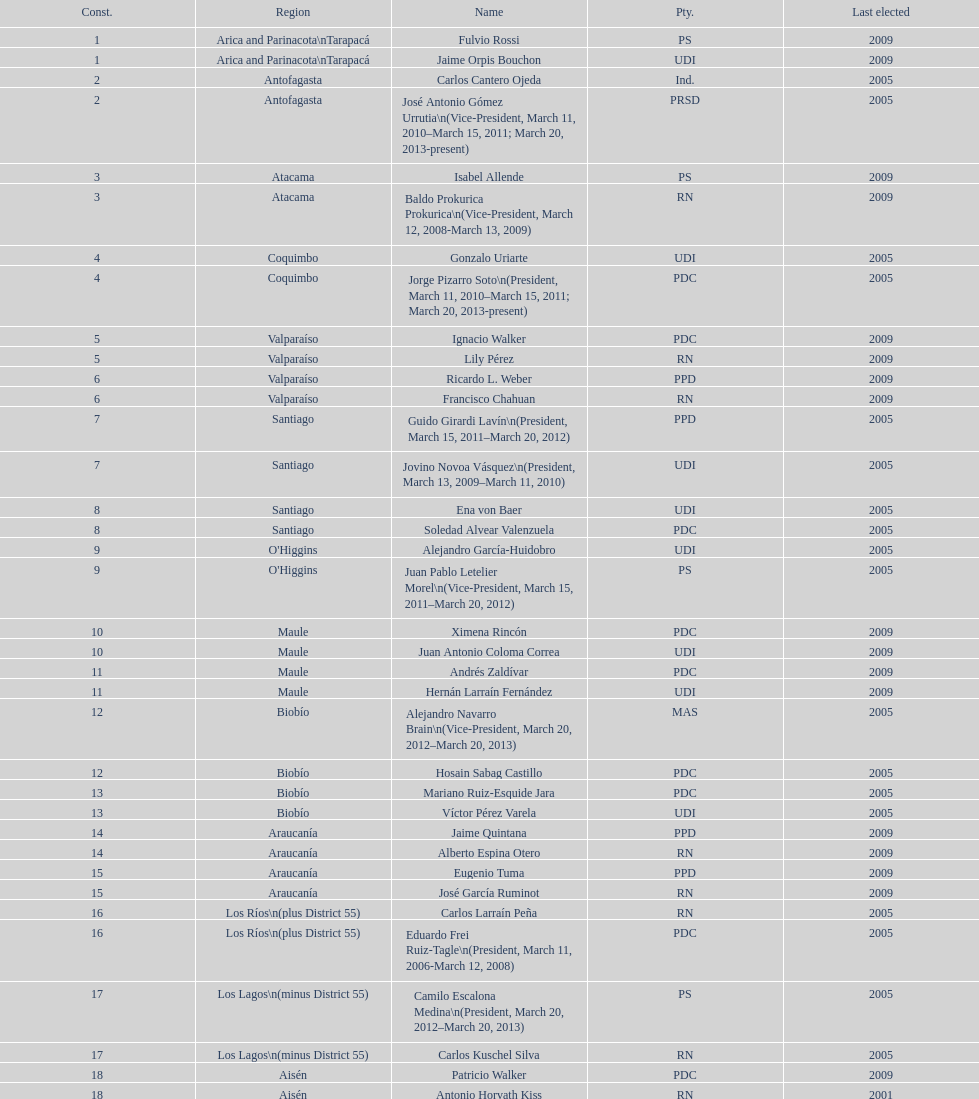How long was baldo prokurica prokurica vice-president? 1 year. 